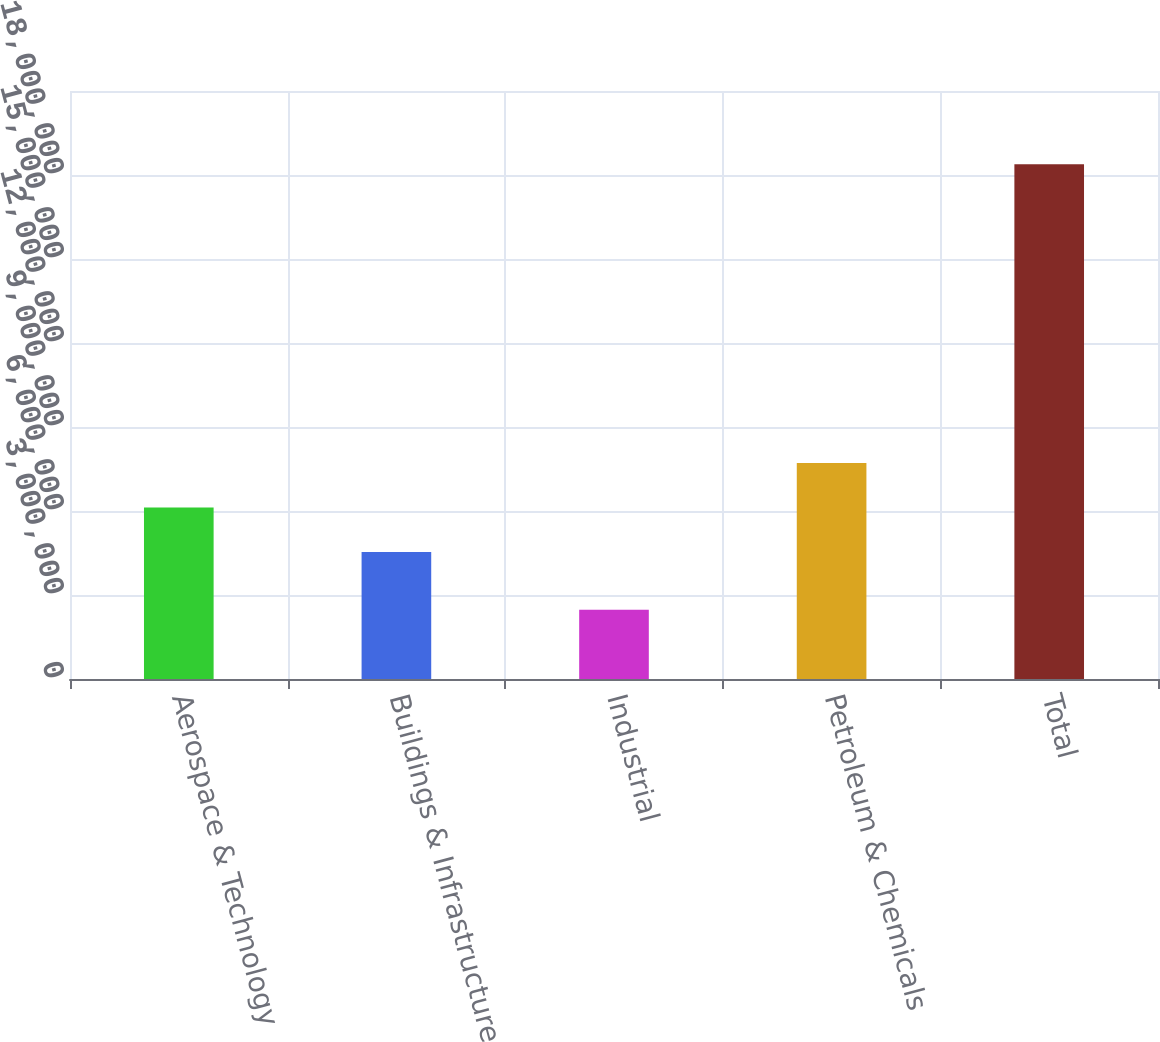Convert chart to OTSL. <chart><loc_0><loc_0><loc_500><loc_500><bar_chart><fcel>Aerospace & Technology<fcel>Buildings & Infrastructure<fcel>Industrial<fcel>Petroleum & Chemicals<fcel>Total<nl><fcel>6.12293e+06<fcel>4.53208e+06<fcel>2.47187e+06<fcel>7.71378e+06<fcel>1.83804e+07<nl></chart> 